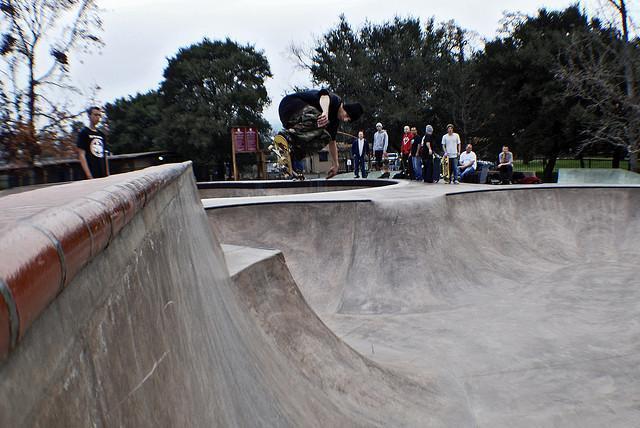How many females are in this picture?
Give a very brief answer. 0. How many people are playing?
Give a very brief answer. 1. How many giraffes are pictured?
Give a very brief answer. 0. 